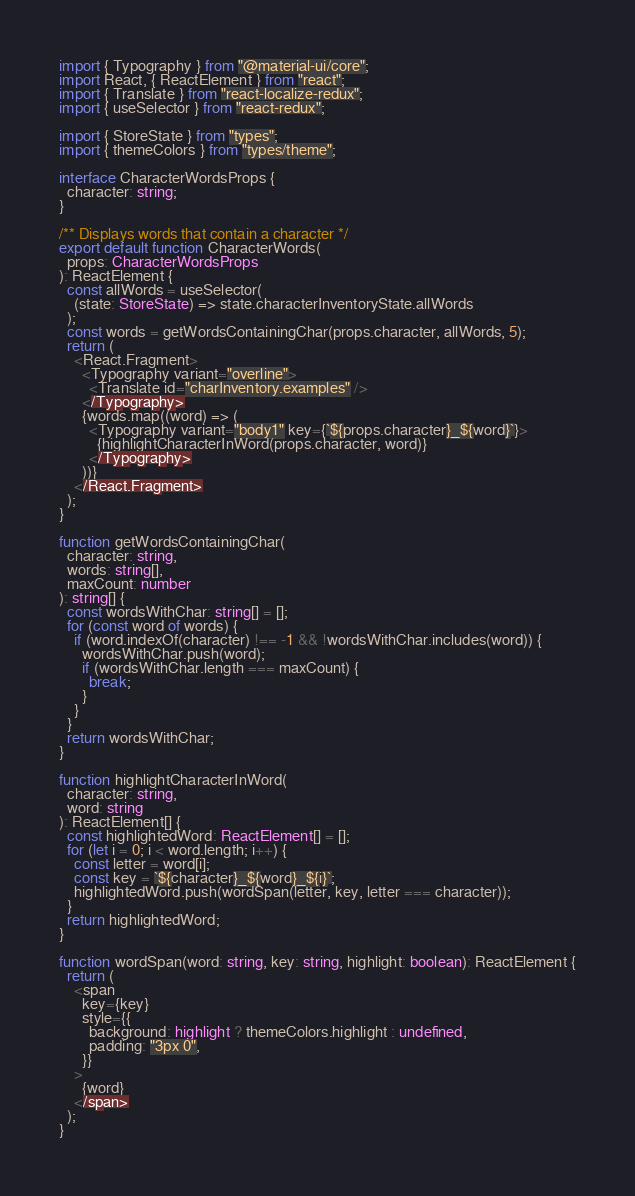Convert code to text. <code><loc_0><loc_0><loc_500><loc_500><_TypeScript_>import { Typography } from "@material-ui/core";
import React, { ReactElement } from "react";
import { Translate } from "react-localize-redux";
import { useSelector } from "react-redux";

import { StoreState } from "types";
import { themeColors } from "types/theme";

interface CharacterWordsProps {
  character: string;
}

/** Displays words that contain a character */
export default function CharacterWords(
  props: CharacterWordsProps
): ReactElement {
  const allWords = useSelector(
    (state: StoreState) => state.characterInventoryState.allWords
  );
  const words = getWordsContainingChar(props.character, allWords, 5);
  return (
    <React.Fragment>
      <Typography variant="overline">
        <Translate id="charInventory.examples" />
      </Typography>
      {words.map((word) => (
        <Typography variant="body1" key={`${props.character}_${word}`}>
          {highlightCharacterInWord(props.character, word)}
        </Typography>
      ))}
    </React.Fragment>
  );
}

function getWordsContainingChar(
  character: string,
  words: string[],
  maxCount: number
): string[] {
  const wordsWithChar: string[] = [];
  for (const word of words) {
    if (word.indexOf(character) !== -1 && !wordsWithChar.includes(word)) {
      wordsWithChar.push(word);
      if (wordsWithChar.length === maxCount) {
        break;
      }
    }
  }
  return wordsWithChar;
}

function highlightCharacterInWord(
  character: string,
  word: string
): ReactElement[] {
  const highlightedWord: ReactElement[] = [];
  for (let i = 0; i < word.length; i++) {
    const letter = word[i];
    const key = `${character}_${word}_${i}`;
    highlightedWord.push(wordSpan(letter, key, letter === character));
  }
  return highlightedWord;
}

function wordSpan(word: string, key: string, highlight: boolean): ReactElement {
  return (
    <span
      key={key}
      style={{
        background: highlight ? themeColors.highlight : undefined,
        padding: "3px 0",
      }}
    >
      {word}
    </span>
  );
}
</code> 